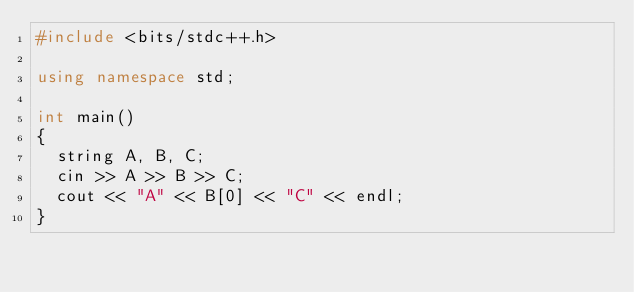<code> <loc_0><loc_0><loc_500><loc_500><_C++_>#include <bits/stdc++.h>

using namespace std;

int main()
{
  string A, B, C;
  cin >> A >> B >> C;
  cout << "A" << B[0] << "C" << endl;
}</code> 